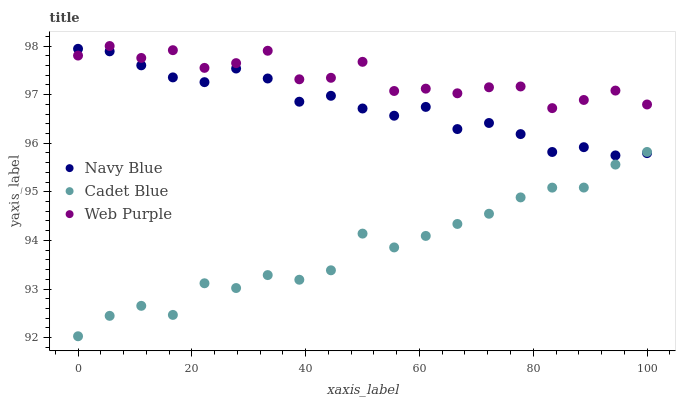Does Cadet Blue have the minimum area under the curve?
Answer yes or no. Yes. Does Web Purple have the maximum area under the curve?
Answer yes or no. Yes. Does Web Purple have the minimum area under the curve?
Answer yes or no. No. Does Cadet Blue have the maximum area under the curve?
Answer yes or no. No. Is Navy Blue the smoothest?
Answer yes or no. Yes. Is Web Purple the roughest?
Answer yes or no. Yes. Is Cadet Blue the smoothest?
Answer yes or no. No. Is Cadet Blue the roughest?
Answer yes or no. No. Does Cadet Blue have the lowest value?
Answer yes or no. Yes. Does Web Purple have the lowest value?
Answer yes or no. No. Does Web Purple have the highest value?
Answer yes or no. Yes. Does Cadet Blue have the highest value?
Answer yes or no. No. Is Cadet Blue less than Web Purple?
Answer yes or no. Yes. Is Web Purple greater than Cadet Blue?
Answer yes or no. Yes. Does Web Purple intersect Navy Blue?
Answer yes or no. Yes. Is Web Purple less than Navy Blue?
Answer yes or no. No. Is Web Purple greater than Navy Blue?
Answer yes or no. No. Does Cadet Blue intersect Web Purple?
Answer yes or no. No. 